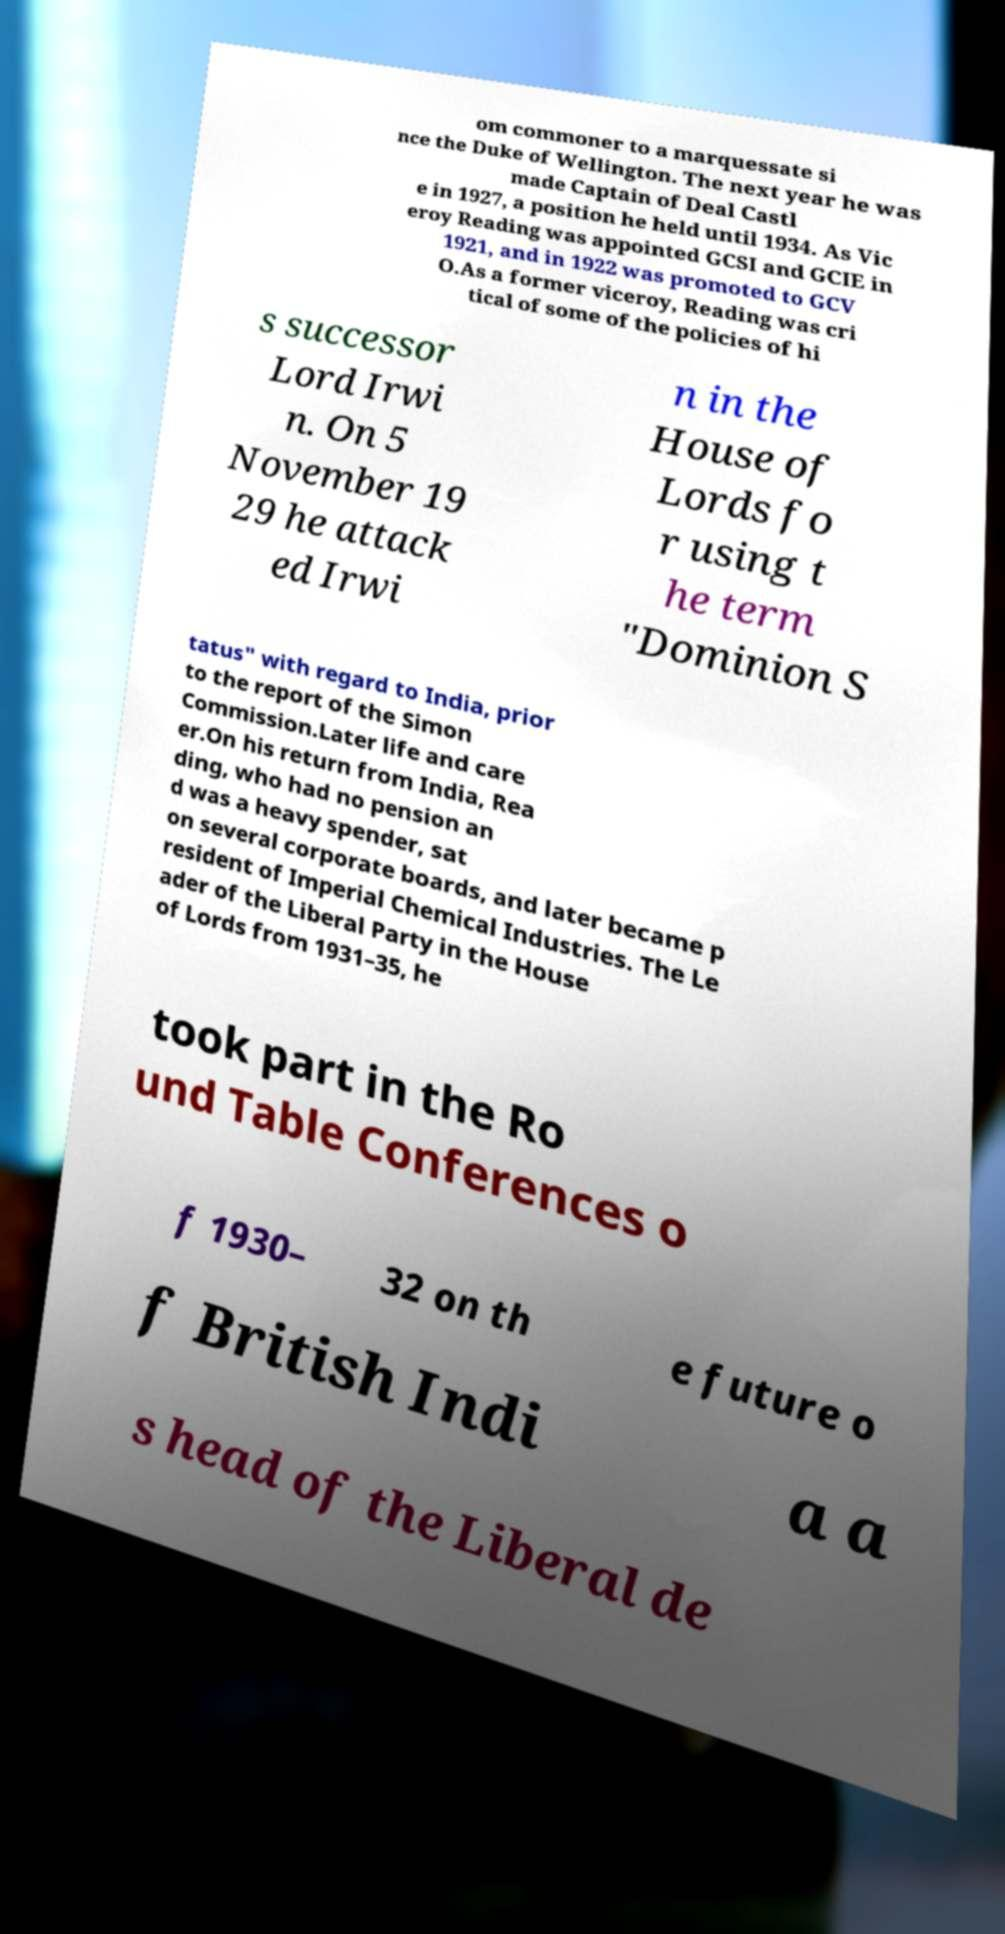Please identify and transcribe the text found in this image. om commoner to a marquessate si nce the Duke of Wellington. The next year he was made Captain of Deal Castl e in 1927, a position he held until 1934. As Vic eroy Reading was appointed GCSI and GCIE in 1921, and in 1922 was promoted to GCV O.As a former viceroy, Reading was cri tical of some of the policies of hi s successor Lord Irwi n. On 5 November 19 29 he attack ed Irwi n in the House of Lords fo r using t he term "Dominion S tatus" with regard to India, prior to the report of the Simon Commission.Later life and care er.On his return from India, Rea ding, who had no pension an d was a heavy spender, sat on several corporate boards, and later became p resident of Imperial Chemical Industries. The Le ader of the Liberal Party in the House of Lords from 1931–35, he took part in the Ro und Table Conferences o f 1930– 32 on th e future o f British Indi a a s head of the Liberal de 